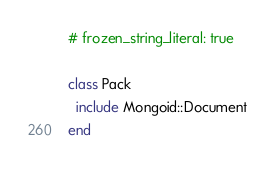Convert code to text. <code><loc_0><loc_0><loc_500><loc_500><_Ruby_># frozen_string_literal: true

class Pack
  include Mongoid::Document
end
</code> 